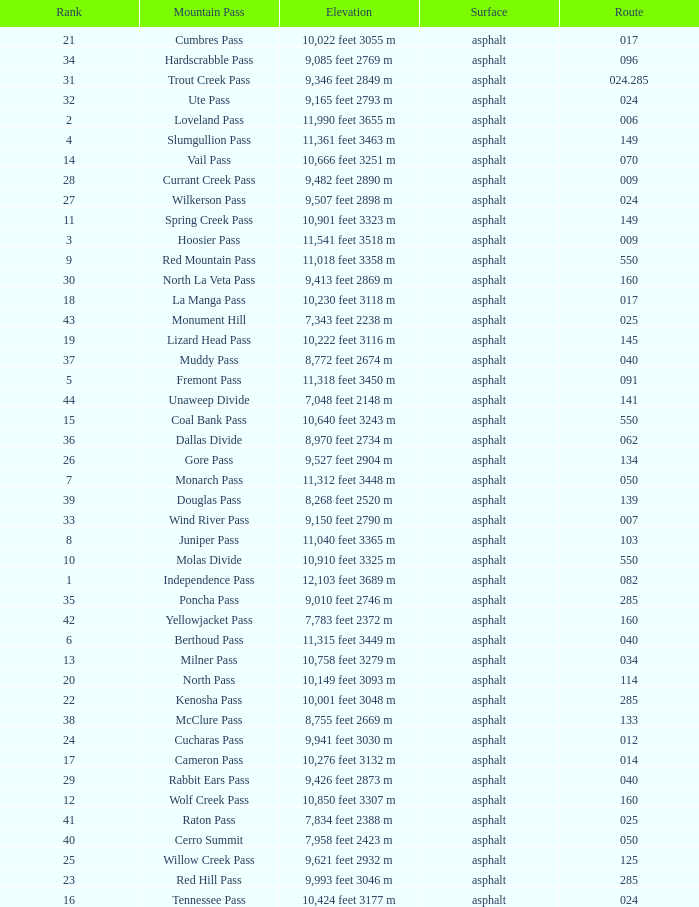On what Route is the mountain with a Rank less than 33 and an Elevation of 11,312 feet 3448 m? 50.0. Could you parse the entire table as a dict? {'header': ['Rank', 'Mountain Pass', 'Elevation', 'Surface', 'Route'], 'rows': [['21', 'Cumbres Pass', '10,022 feet 3055 m', 'asphalt', '017'], ['34', 'Hardscrabble Pass', '9,085 feet 2769 m', 'asphalt', '096'], ['31', 'Trout Creek Pass', '9,346 feet 2849 m', 'asphalt', '024.285'], ['32', 'Ute Pass', '9,165 feet 2793 m', 'asphalt', '024'], ['2', 'Loveland Pass', '11,990 feet 3655 m', 'asphalt', '006'], ['4', 'Slumgullion Pass', '11,361 feet 3463 m', 'asphalt', '149'], ['14', 'Vail Pass', '10,666 feet 3251 m', 'asphalt', '070'], ['28', 'Currant Creek Pass', '9,482 feet 2890 m', 'asphalt', '009'], ['27', 'Wilkerson Pass', '9,507 feet 2898 m', 'asphalt', '024'], ['11', 'Spring Creek Pass', '10,901 feet 3323 m', 'asphalt', '149'], ['3', 'Hoosier Pass', '11,541 feet 3518 m', 'asphalt', '009'], ['9', 'Red Mountain Pass', '11,018 feet 3358 m', 'asphalt', '550'], ['30', 'North La Veta Pass', '9,413 feet 2869 m', 'asphalt', '160'], ['18', 'La Manga Pass', '10,230 feet 3118 m', 'asphalt', '017'], ['43', 'Monument Hill', '7,343 feet 2238 m', 'asphalt', '025'], ['19', 'Lizard Head Pass', '10,222 feet 3116 m', 'asphalt', '145'], ['37', 'Muddy Pass', '8,772 feet 2674 m', 'asphalt', '040'], ['5', 'Fremont Pass', '11,318 feet 3450 m', 'asphalt', '091'], ['44', 'Unaweep Divide', '7,048 feet 2148 m', 'asphalt', '141'], ['15', 'Coal Bank Pass', '10,640 feet 3243 m', 'asphalt', '550'], ['36', 'Dallas Divide', '8,970 feet 2734 m', 'asphalt', '062'], ['26', 'Gore Pass', '9,527 feet 2904 m', 'asphalt', '134'], ['7', 'Monarch Pass', '11,312 feet 3448 m', 'asphalt', '050'], ['39', 'Douglas Pass', '8,268 feet 2520 m', 'asphalt', '139'], ['33', 'Wind River Pass', '9,150 feet 2790 m', 'asphalt', '007'], ['8', 'Juniper Pass', '11,040 feet 3365 m', 'asphalt', '103'], ['10', 'Molas Divide', '10,910 feet 3325 m', 'asphalt', '550'], ['1', 'Independence Pass', '12,103 feet 3689 m', 'asphalt', '082'], ['35', 'Poncha Pass', '9,010 feet 2746 m', 'asphalt', '285'], ['42', 'Yellowjacket Pass', '7,783 feet 2372 m', 'asphalt', '160'], ['6', 'Berthoud Pass', '11,315 feet 3449 m', 'asphalt', '040'], ['13', 'Milner Pass', '10,758 feet 3279 m', 'asphalt', '034'], ['20', 'North Pass', '10,149 feet 3093 m', 'asphalt', '114'], ['22', 'Kenosha Pass', '10,001 feet 3048 m', 'asphalt', '285'], ['38', 'McClure Pass', '8,755 feet 2669 m', 'asphalt', '133'], ['24', 'Cucharas Pass', '9,941 feet 3030 m', 'asphalt', '012'], ['17', 'Cameron Pass', '10,276 feet 3132 m', 'asphalt', '014'], ['29', 'Rabbit Ears Pass', '9,426 feet 2873 m', 'asphalt', '040'], ['12', 'Wolf Creek Pass', '10,850 feet 3307 m', 'asphalt', '160'], ['41', 'Raton Pass', '7,834 feet 2388 m', 'asphalt', '025'], ['40', 'Cerro Summit', '7,958 feet 2423 m', 'asphalt', '050'], ['25', 'Willow Creek Pass', '9,621 feet 2932 m', 'asphalt', '125'], ['23', 'Red Hill Pass', '9,993 feet 3046 m', 'asphalt', '285'], ['16', 'Tennessee Pass', '10,424 feet 3177 m', 'asphalt', '024']]} 